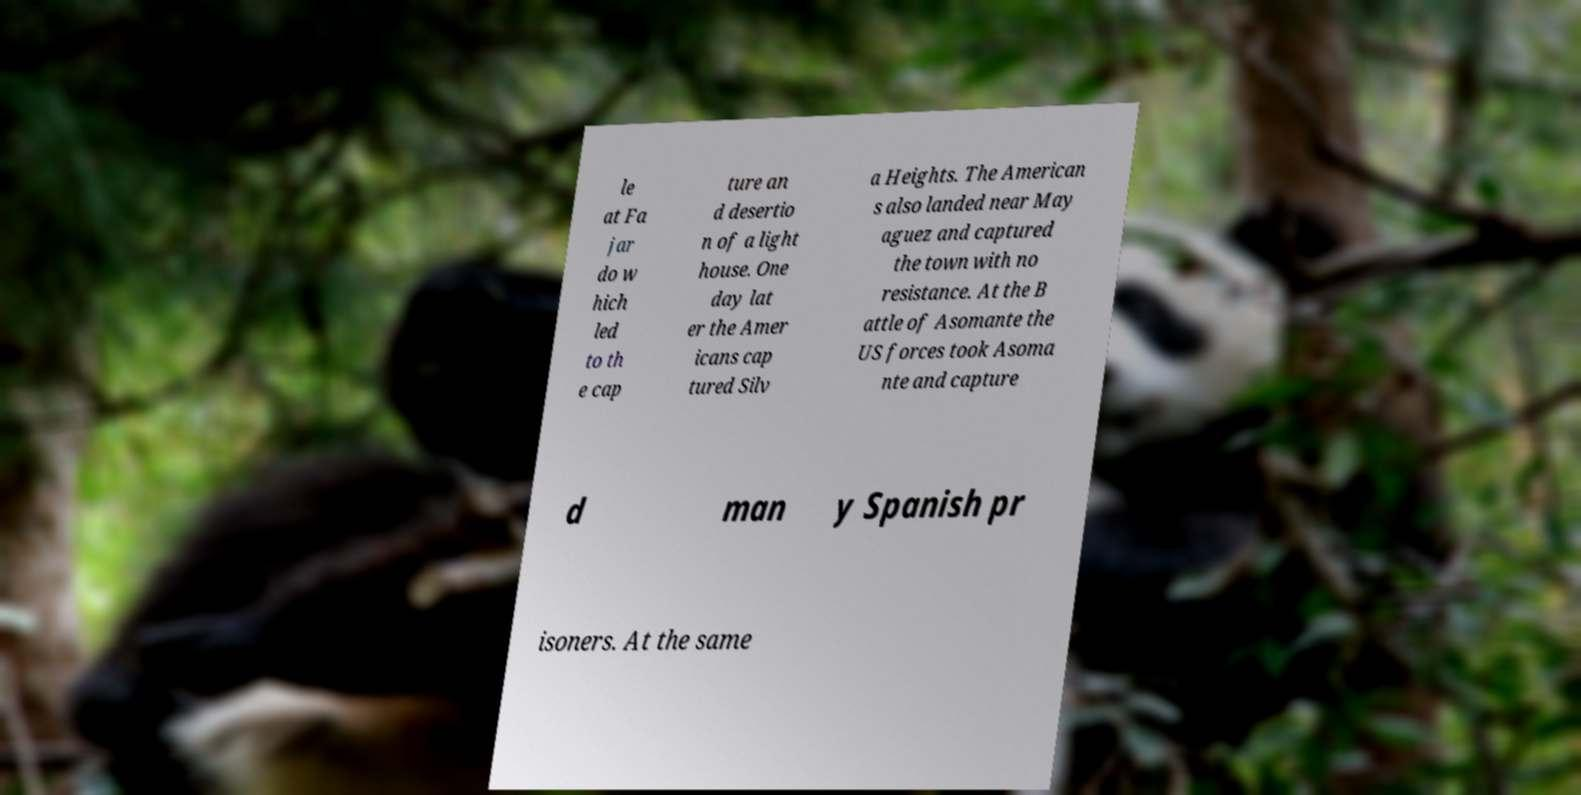What messages or text are displayed in this image? I need them in a readable, typed format. le at Fa jar do w hich led to th e cap ture an d desertio n of a light house. One day lat er the Amer icans cap tured Silv a Heights. The American s also landed near May aguez and captured the town with no resistance. At the B attle of Asomante the US forces took Asoma nte and capture d man y Spanish pr isoners. At the same 